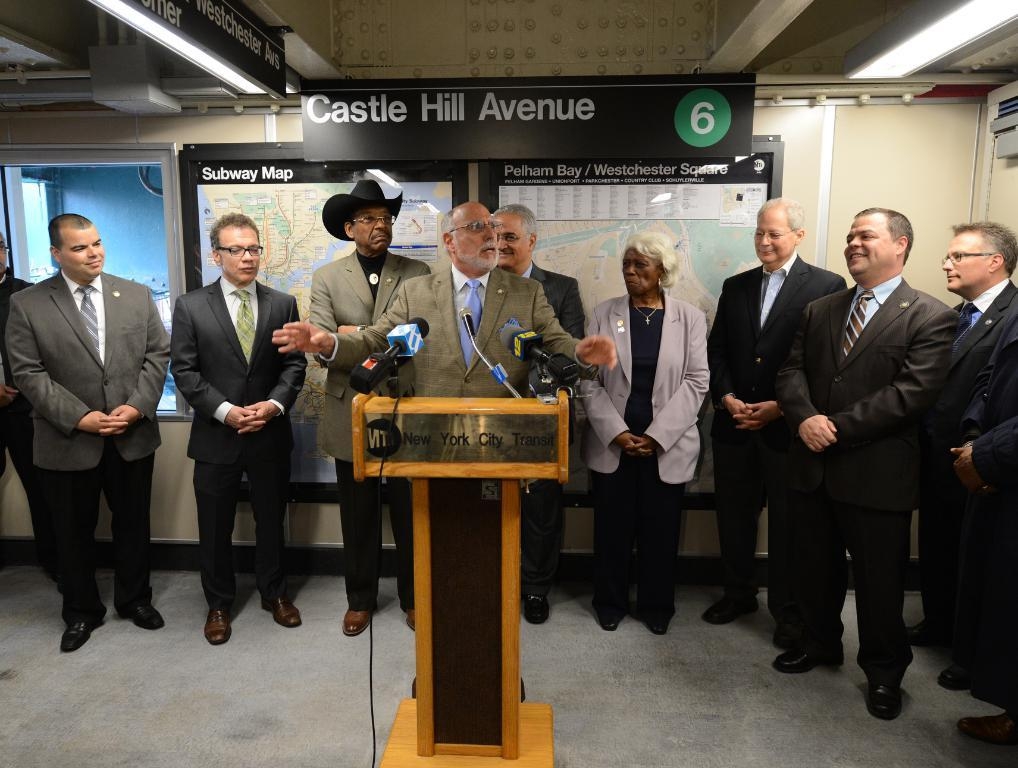How many people are in the group visible in the image? There is a group of people in the image, but the exact number cannot be determined from the provided facts. What is the purpose of the podium in the image? The presence of a podium suggests that it might be used for public speaking or presentations. What are the microphones used for in the image? The microphones are likely used for amplifying sound during speeches or presentations. What can be seen in the background of the image? There are posters in the background of the image. What is the weight of the cast in the image? There is no cast present in the image, so it is not possible to determine its weight. 